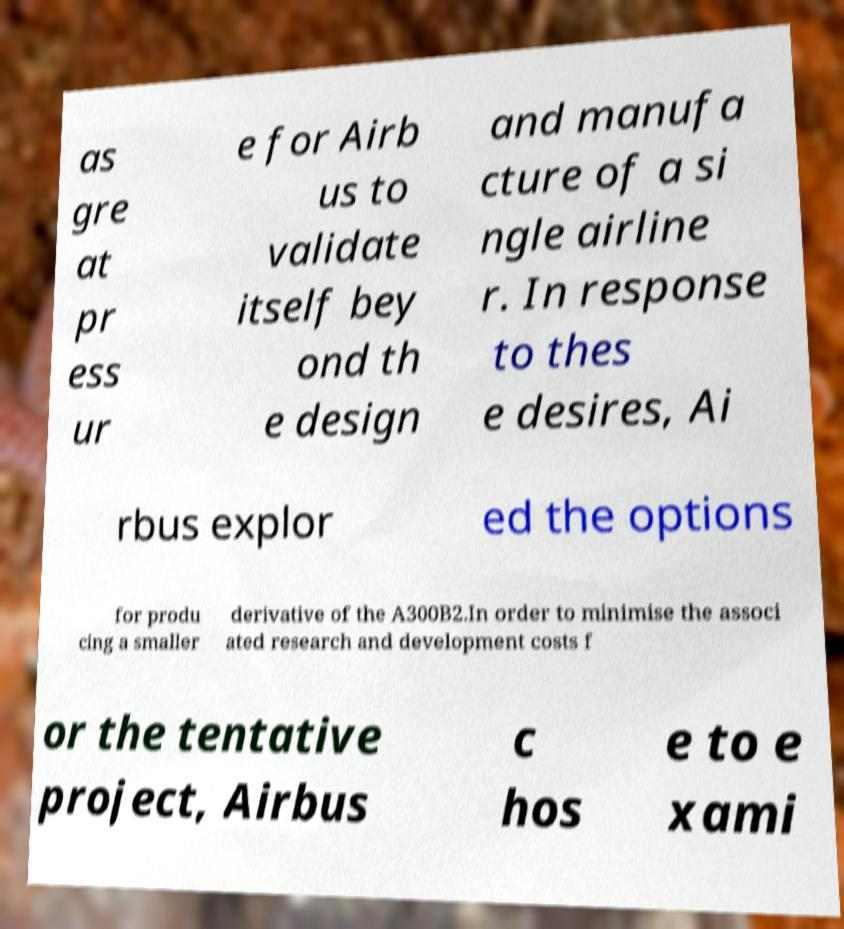I need the written content from this picture converted into text. Can you do that? as gre at pr ess ur e for Airb us to validate itself bey ond th e design and manufa cture of a si ngle airline r. In response to thes e desires, Ai rbus explor ed the options for produ cing a smaller derivative of the A300B2.In order to minimise the associ ated research and development costs f or the tentative project, Airbus c hos e to e xami 